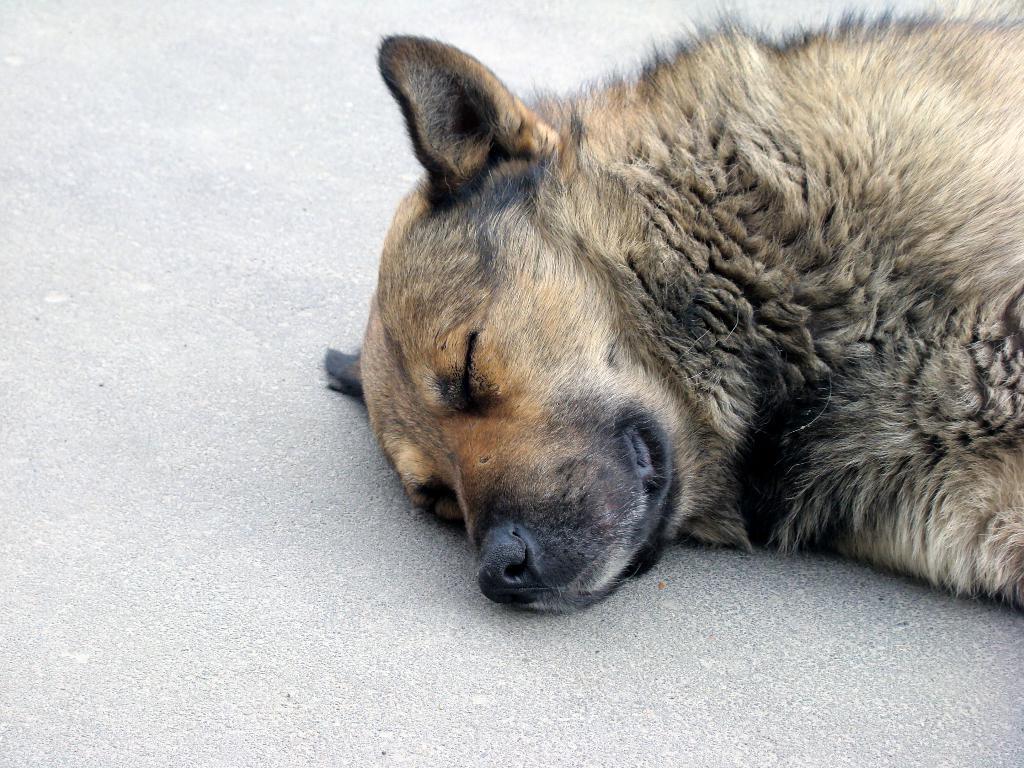Can you describe this image briefly? In this picture we can see a dog lying on the ground. 